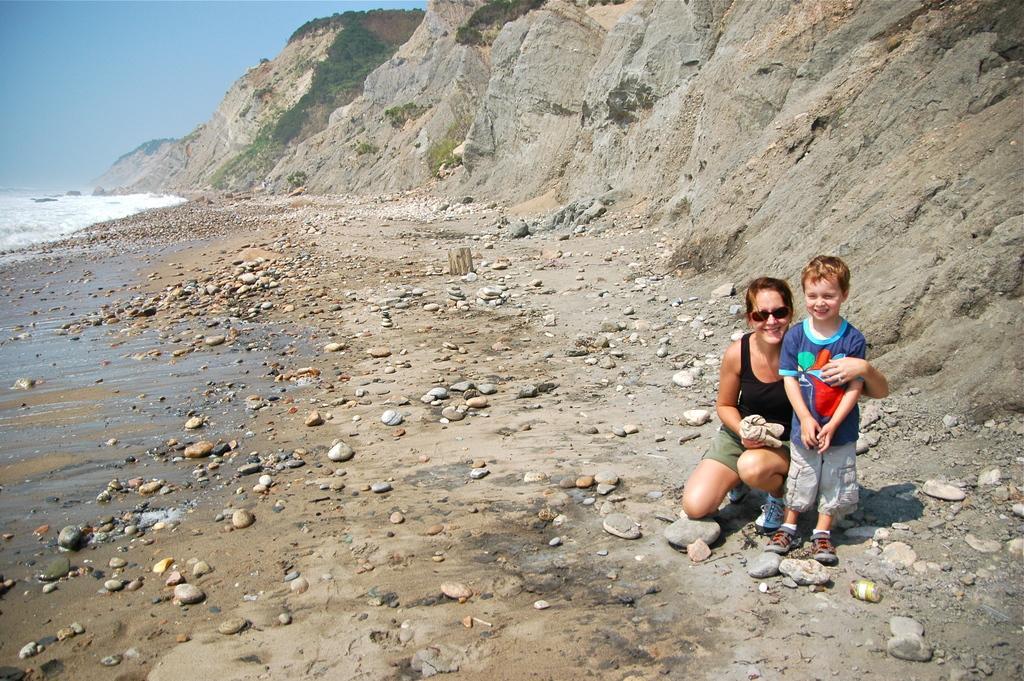How would you summarize this image in a sentence or two? This image consists of a woman wearing black dress and holding a kid. At the bottom, there are rocks. This image is clicked near the beach. To the left, there is water. To the right, there are mountains made up of rocks. 